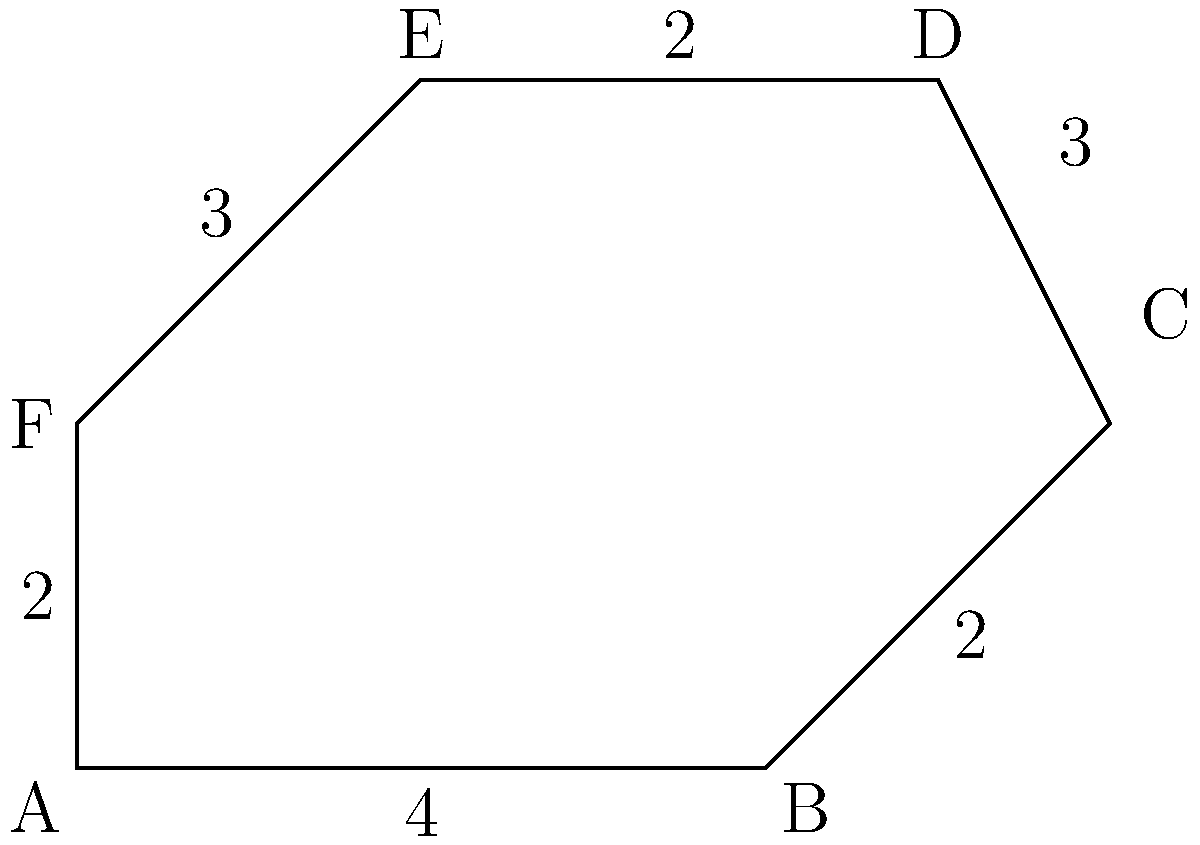Your child's addiction recovery progress is measured by their ability to solve complex problems. Calculate the perimeter of this irregular hexagon to determine their next milestone. All measurements are in meters. To calculate the perimeter of this irregular hexagon, we need to sum up the lengths of all sides:

1. Side AB: Given as 4 meters
2. Side BC: Given as 2 meters
3. Side CD: Given as 3 meters
4. Side DE: Given as 2 meters
5. Side EF: Given as 3 meters
6. Side FA: Given as 2 meters

Now, let's add all these lengths:

$$\text{Perimeter} = AB + BC + CD + DE + EF + FA$$
$$\text{Perimeter} = 4 + 2 + 3 + 2 + 3 + 2$$
$$\text{Perimeter} = 16\text{ meters}$$

Therefore, the perimeter of the irregular hexagon is 16 meters.
Answer: 16 meters 